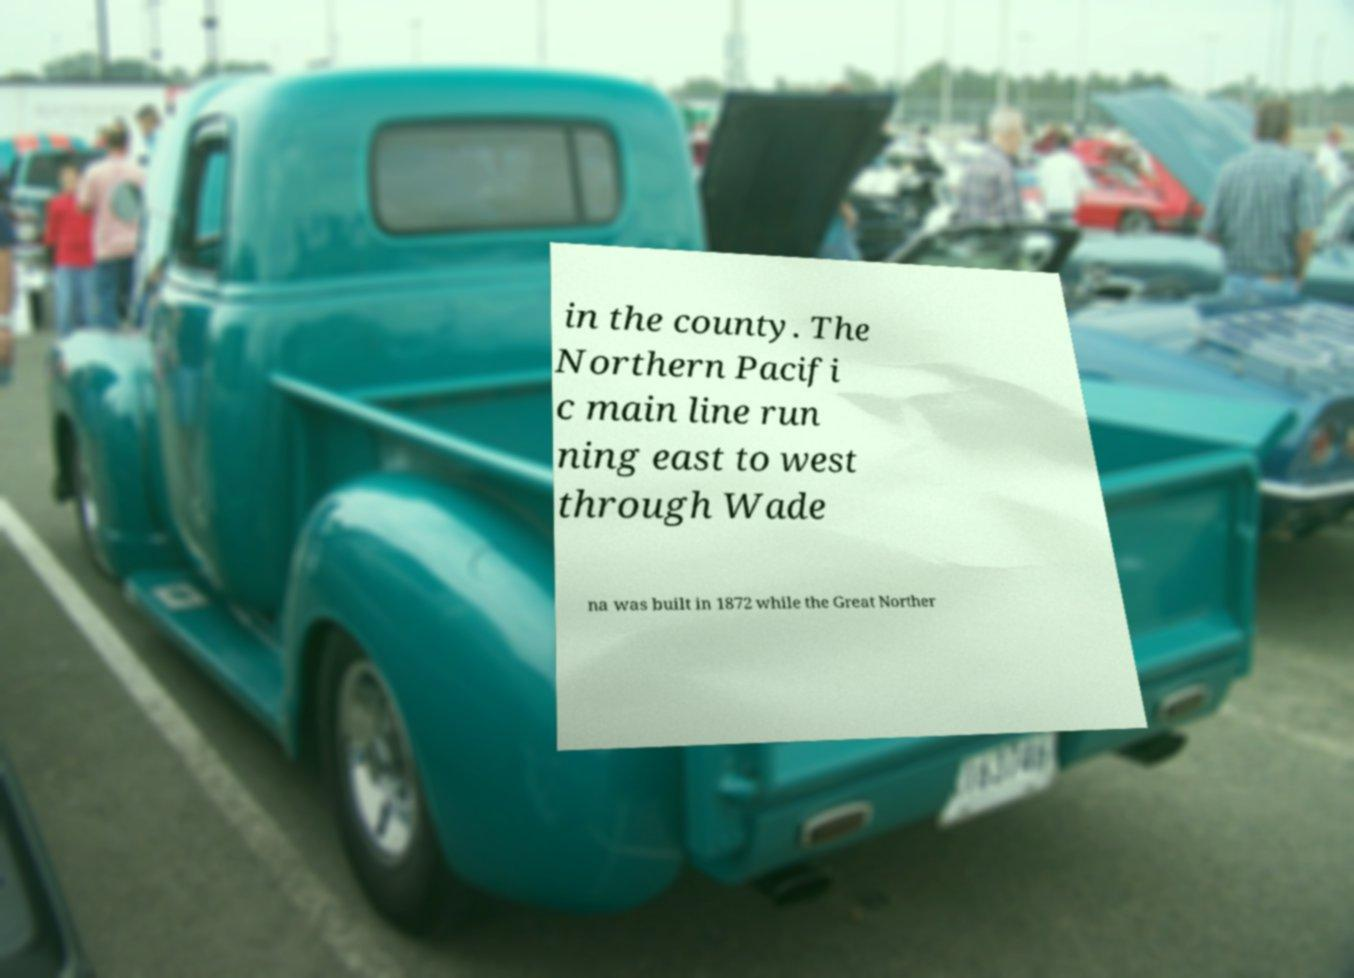Please read and relay the text visible in this image. What does it say? in the county. The Northern Pacifi c main line run ning east to west through Wade na was built in 1872 while the Great Norther 